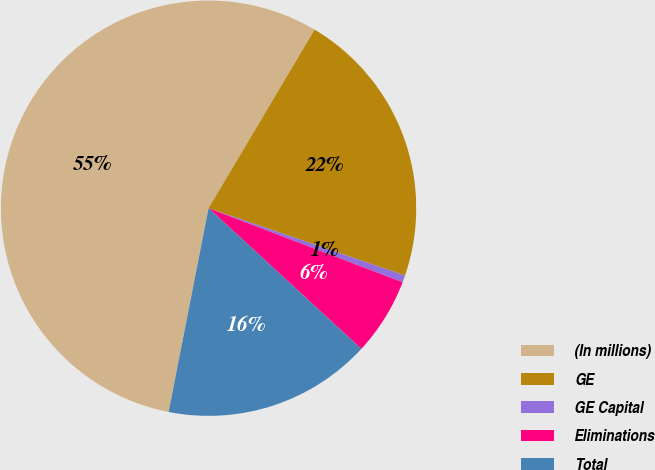Convert chart. <chart><loc_0><loc_0><loc_500><loc_500><pie_chart><fcel>(In millions)<fcel>GE<fcel>GE Capital<fcel>Eliminations<fcel>Total<nl><fcel>55.45%<fcel>21.73%<fcel>0.55%<fcel>6.04%<fcel>16.24%<nl></chart> 